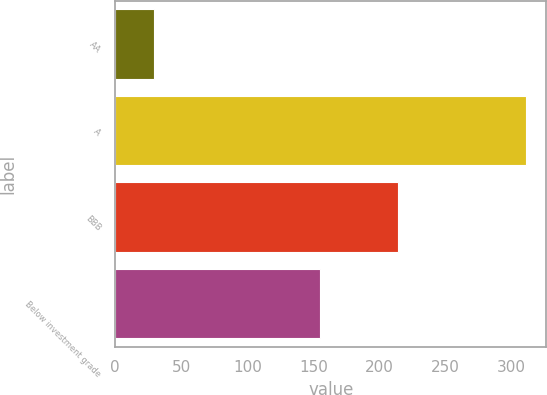Convert chart. <chart><loc_0><loc_0><loc_500><loc_500><bar_chart><fcel>AA<fcel>A<fcel>BBB<fcel>Below investment grade<nl><fcel>29<fcel>311<fcel>214<fcel>155<nl></chart> 